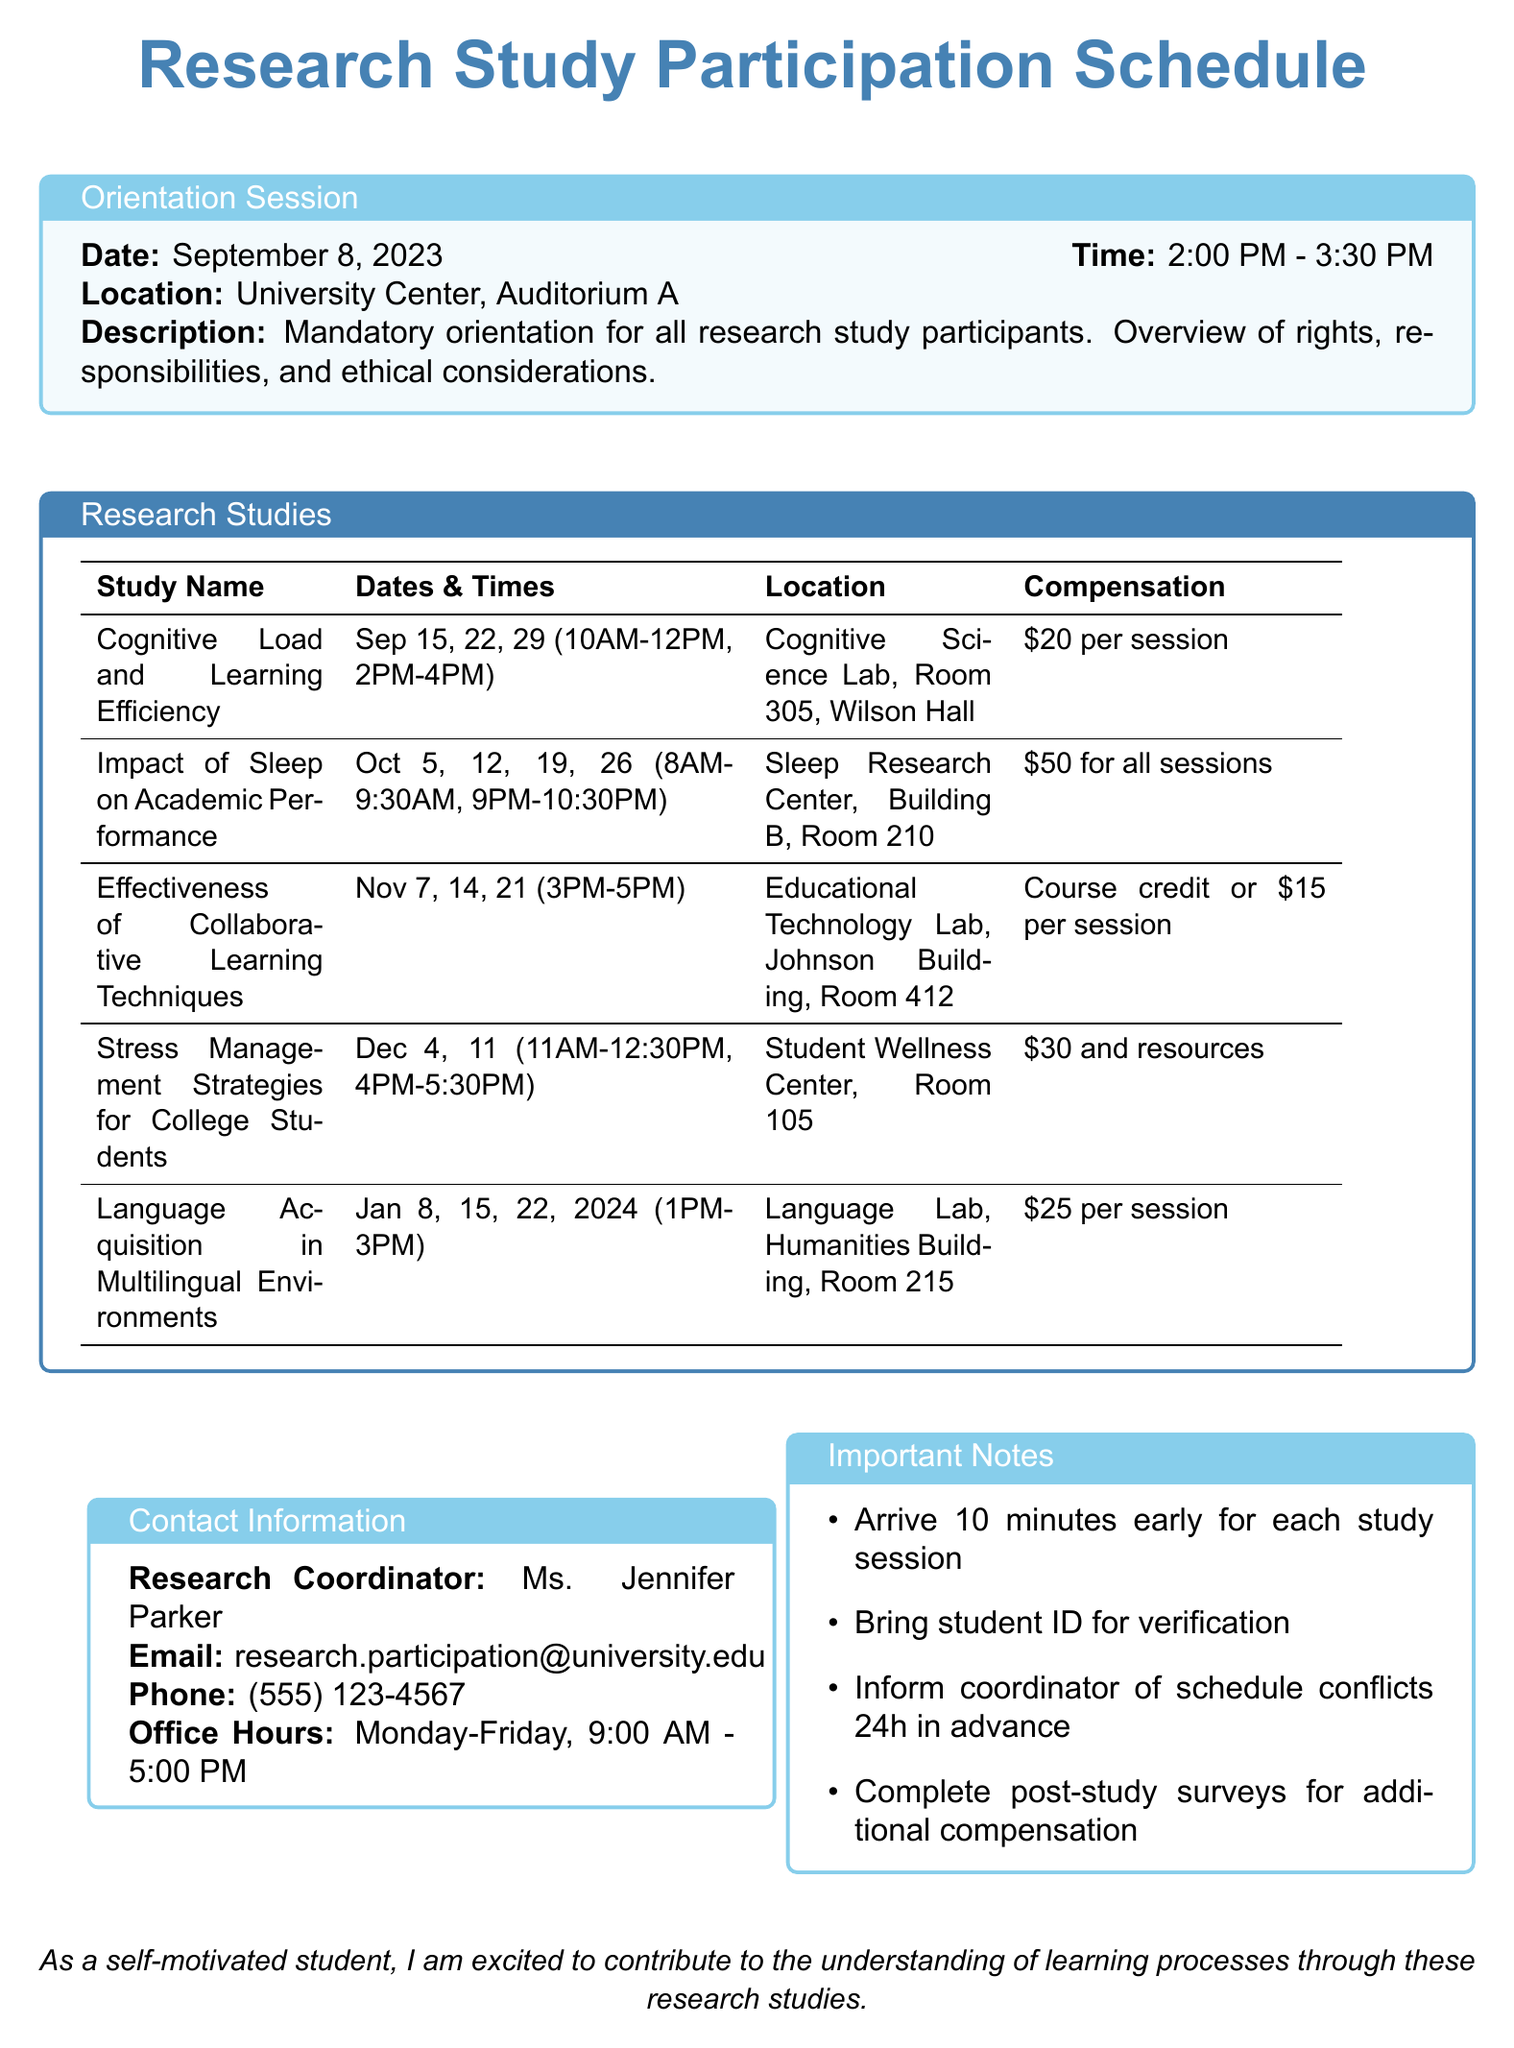what is the date of the orientation session? The orientation session date is explicitly mentioned in the document as September 8, 2023.
Answer: September 8, 2023 who is the principal investigator for the study on cognitive load? The document specifies Dr. Sarah Chen as the principal investigator for the cognitive load study.
Answer: Dr. Sarah Chen what is the compensation for participating in the study on sleep? The compensation details for the sleep study are included in the document as $50 for completing all sessions.
Answer: $50 for completing all sessions how many dates are provided for the effectiveness of collaborative learning techniques study? The document lists three specific dates for this study, indicating the number of sessions.
Answer: 3 where will the stress management strategies study take place? The location of the stress management strategies study is detailed in the document as the Student Wellness Center, Room 105.
Answer: Student Wellness Center, Room 105 what is the requirement for participating in the language acquisition study? The document states that bilingual or multilingual speakers aged 18-30 are eligible for this study.
Answer: Bilingual or multilingual speakers, age 18-30 how long is the orientation session scheduled for? The document mentions that the orientation session is set to occur for 1.5 hours, specifically from 2:00 PM to 3:30 PM.
Answer: 1.5 hours what is the latest date for the cognitive load study sessions? The latest date for the cognitive load study sessions is explicitly stated in the document as September 29, 2023.
Answer: September 29, 2023 what is the office hours for the research coordinator? The office hours for the research coordinator are specified in the document from Monday to Friday, 9:00 AM to 5:00 PM.
Answer: Monday-Friday, 9:00 AM - 5:00 PM 